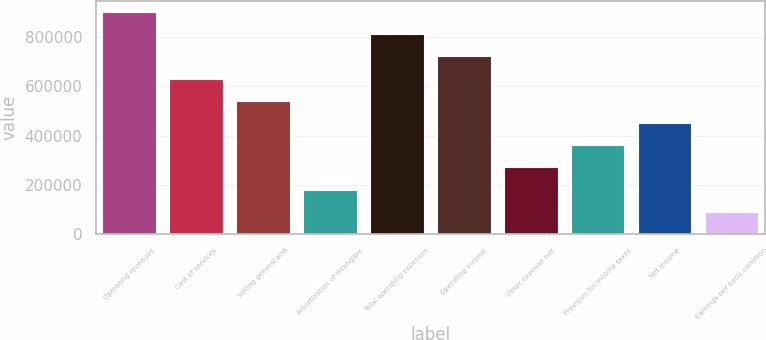Convert chart to OTSL. <chart><loc_0><loc_0><loc_500><loc_500><bar_chart><fcel>Operating revenues<fcel>Cost of services<fcel>Selling general and<fcel>Amortization of intangible<fcel>Total operating expenses<fcel>Operating income<fcel>Other expense net<fcel>Provision for income taxes<fcel>Net income<fcel>Earnings per basic common<nl><fcel>900941<fcel>630659<fcel>540565<fcel>180189<fcel>810847<fcel>720753<fcel>270283<fcel>360377<fcel>450471<fcel>90095.4<nl></chart> 